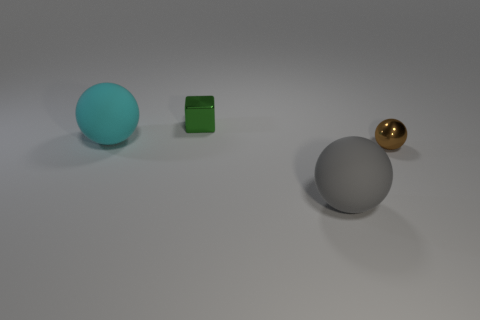What might be the purpose of arranging these objects like this? This arrangement of objects might be for a visual composition exercise, possibly related to the study of colors, textures, lighting, and shape interactions in a controlled setting. It could serve as a test for rendering techniques or a demonstration of object contrast and balance in a 3D modeling or art presentation context. 